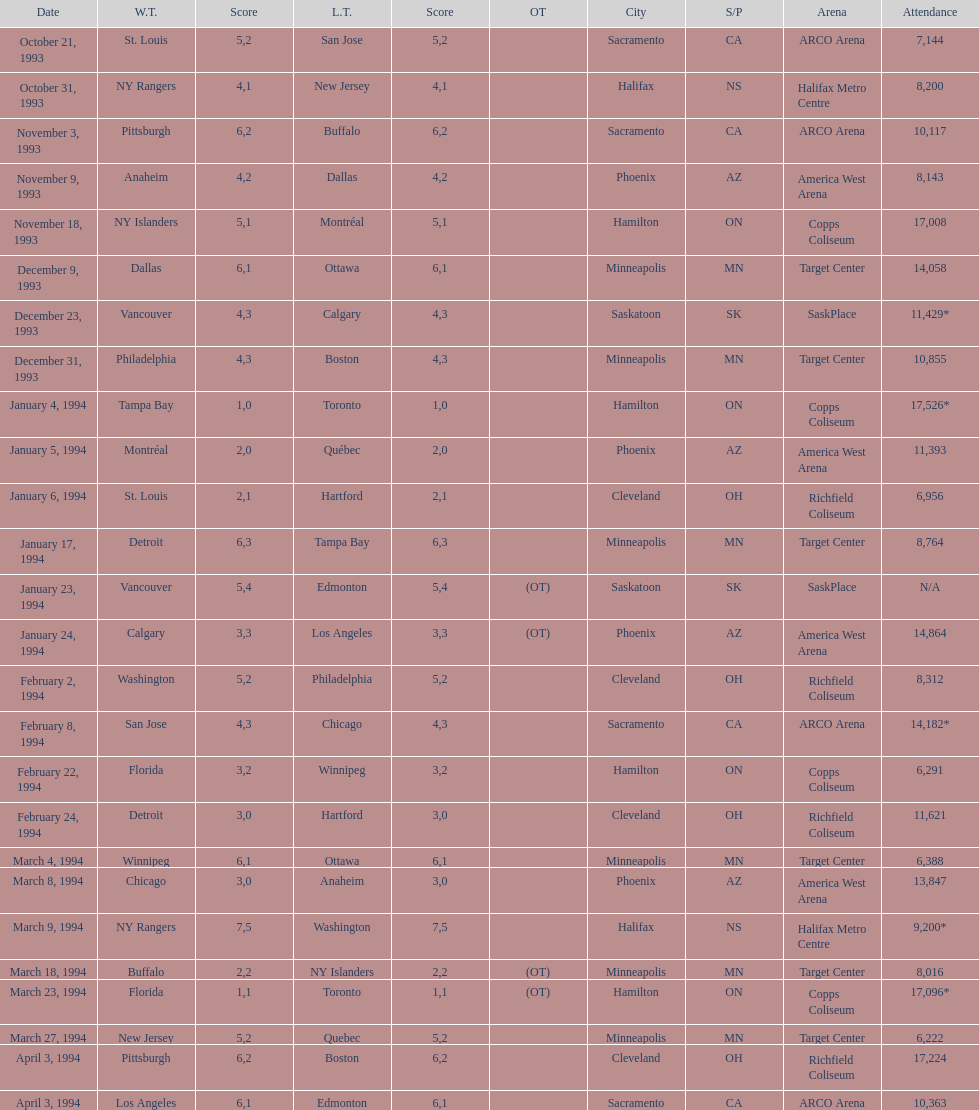How many games have been held in minneapolis? 6. 